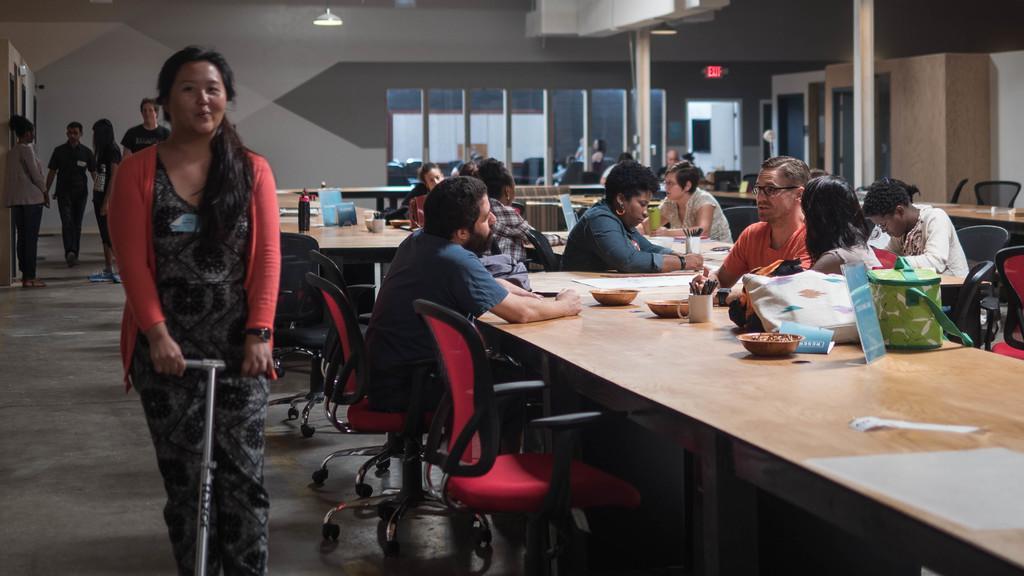Describe this image in one or two sentences. In this picture there are group of people who are sitting on the chair. There is a bowl,bottle and few things on the table. There is a woman standing on the stand. At the back there are some persons. 